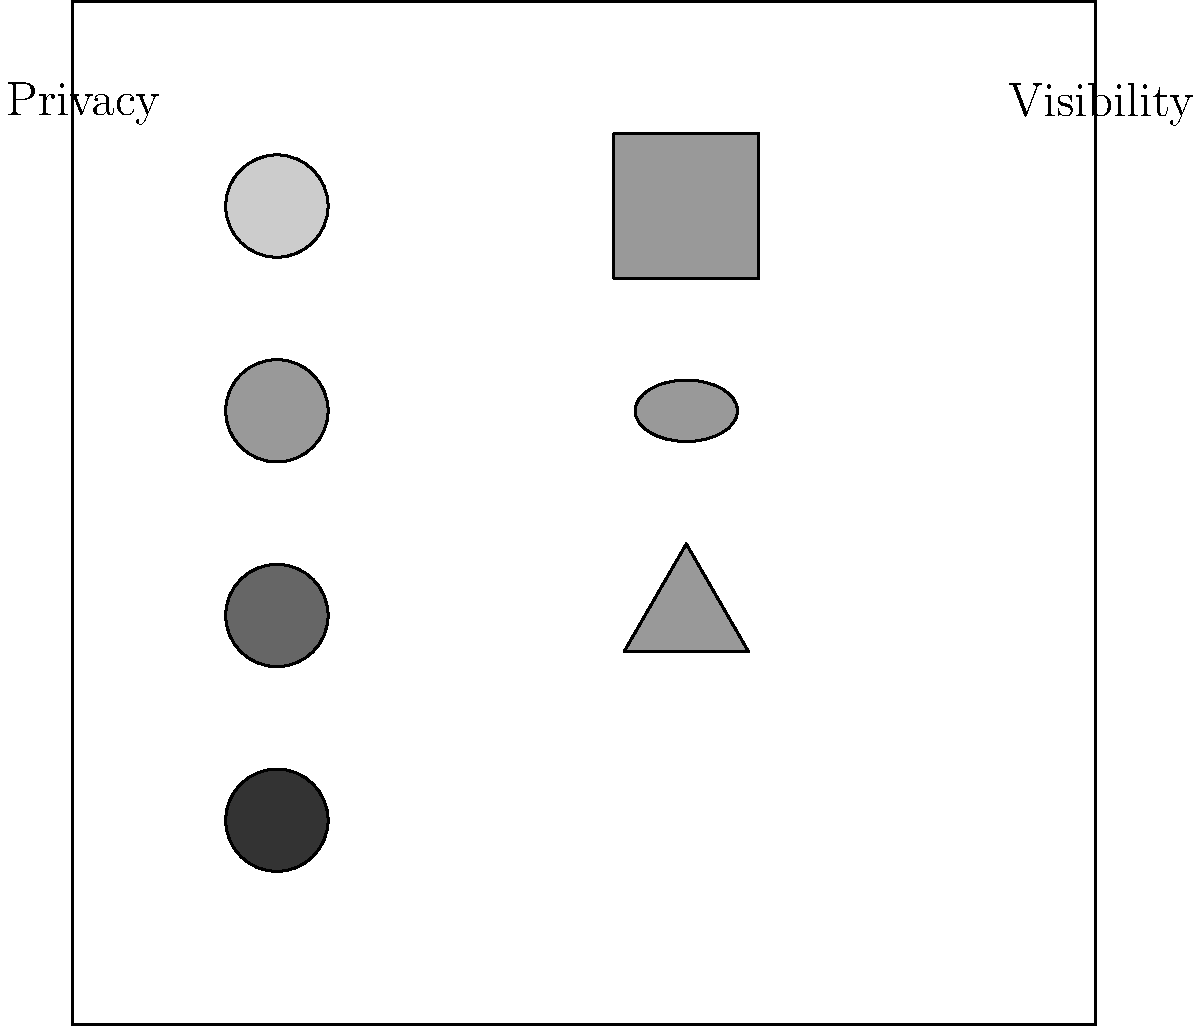In this social media interface visualization, which privacy setting corresponds to the most restricted content visibility? To determine the most restricted privacy setting, we need to analyze the relationship between the privacy indicators and content visibility icons:

1. The left side of the interface shows four circular indicators representing privacy levels.
2. The right side displays three icons representing content visibility.
3. The privacy indicators gradually darken from top to bottom, suggesting increasing privacy levels.
4. The content visibility icons change shape from top to bottom:
   - Top: Square (represents public visibility)
   - Middle: Oval (represents friends or connections)
   - Bottom: Triangle (represents most restricted visibility)
5. The darkest privacy indicator (bottom left) aligns with the triangle icon (bottom right).
6. This alignment suggests that the darkest privacy setting corresponds to the most restricted content visibility.

Therefore, the bottom (darkest) privacy indicator represents the most restricted privacy setting.
Answer: Bottom (darkest) indicator 